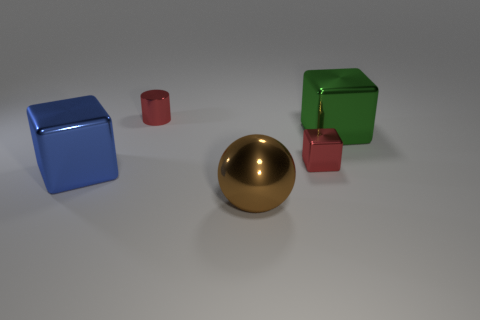Is there a green metal cube behind the big brown sphere in front of the large metallic cube right of the big blue shiny block?
Provide a short and direct response. Yes. How many other things are the same shape as the brown metal object?
Your response must be concise. 0. There is a metal thing that is both left of the green metallic cube and right of the big ball; what shape is it?
Make the answer very short. Cube. There is a tiny object that is right of the brown metal thing in front of the red object to the right of the large brown thing; what color is it?
Provide a short and direct response. Red. Is the number of shiny objects on the right side of the tiny cube greater than the number of small red objects that are to the right of the large green metallic object?
Provide a succinct answer. Yes. What number of other things are the same size as the green metal object?
Offer a very short reply. 2. There is a cube that is the same color as the cylinder; what size is it?
Give a very brief answer. Small. There is a red object in front of the large block to the right of the tiny red block; what is it made of?
Give a very brief answer. Metal. There is a big green thing; are there any red objects in front of it?
Your response must be concise. Yes. Are there more red cylinders that are behind the blue cube than brown matte spheres?
Ensure brevity in your answer.  Yes. 